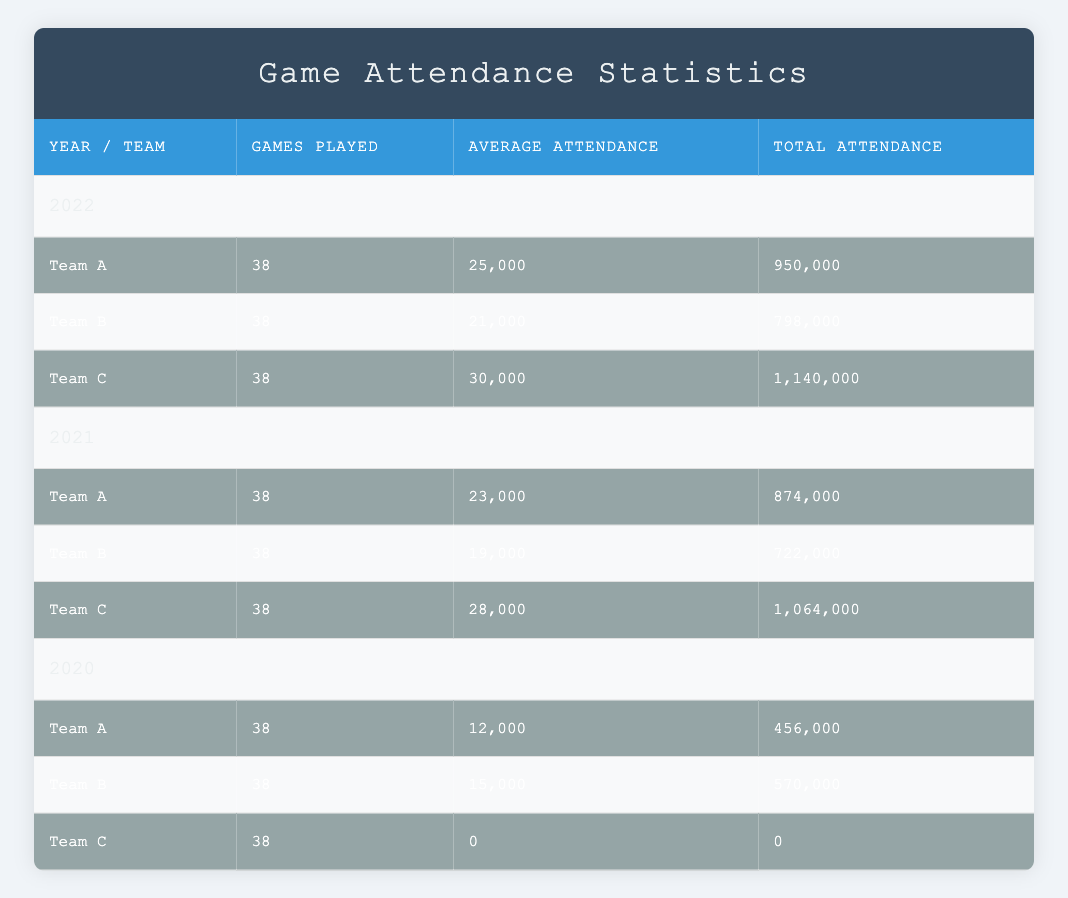What was Team C's average attendance in 2022? The table shows that Team C had an average attendance of 30,000 in 2022.
Answer: 30,000 How many total games were played by Team A across all three years? According to the table, Team A played 38 games in each of the three years (2020, 2021, and 2022), so the total number of games played is 38 + 38 + 38 = 114.
Answer: 114 Did Team B ever have an average attendance of over 20,000? In the table, we see Team B had an average attendance of 21,000 in 2022, which is over 20,000. Therefore, the answer is yes.
Answer: Yes What is the total attendance of Team A in 2021 and 2022 combined? Team A's total attendance in 2021 is 874,000, and in 2022 is 950,000. Adding those together gives 874,000 + 950,000 = 1,824,000.
Answer: 1,824,000 In which year did Team C have the highest average attendance? Looking at the table, Team C's average attendance was 28,000 in 2021, 30,000 in 2022, and 0 in 2020. Thus, the highest average attendance was in 2022.
Answer: 2022 What is the difference in total attendance for Team C between 2021 and 2022? Team C had a total attendance of 1,064,000 in 2021 and 1,140,000 in 2022. To find the difference, we subtract: 1,140,000 - 1,064,000 = 76,000.
Answer: 76,000 Is the average attendance for Team A higher in 2021 or 2022? The average attendance for Team A was 23,000 in 2021 and 25,000 in 2022. Since 25,000 is greater than 23,000, Team A's average in 2022 was higher.
Answer: 2022 How many total attendees were recorded for Team B in 2020 and 2021 combined? Team B's total attendance in 2020 was 570,000 and in 2021 was 722,000. Adding both gives: 570,000 + 722,000 = 1,292,000.
Answer: 1,292,000 Which team had the lowest average attendance in 2020? From the data, Team C had an average attendance of 0 in 2020, which is lower than that of Team A and Team B.
Answer: Team C 